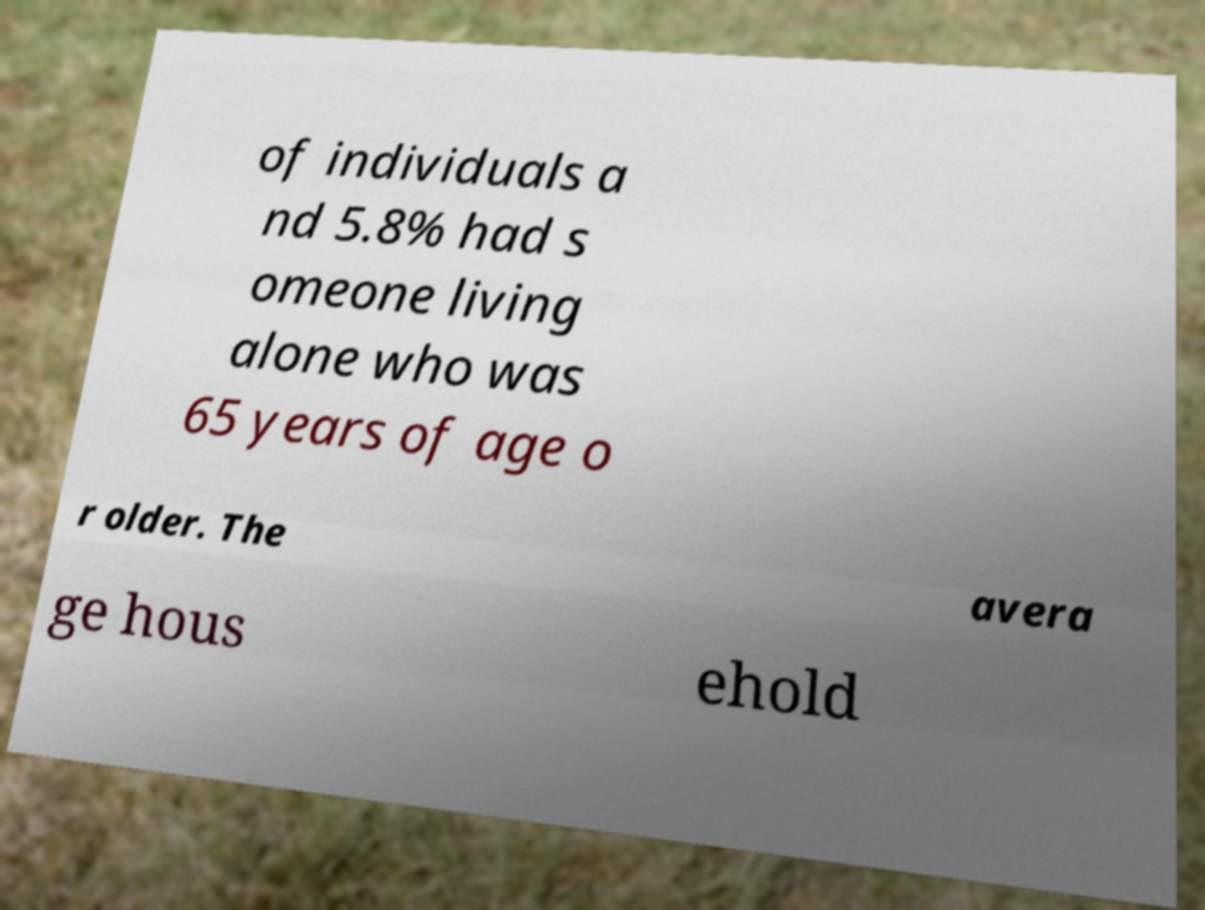Can you accurately transcribe the text from the provided image for me? of individuals a nd 5.8% had s omeone living alone who was 65 years of age o r older. The avera ge hous ehold 